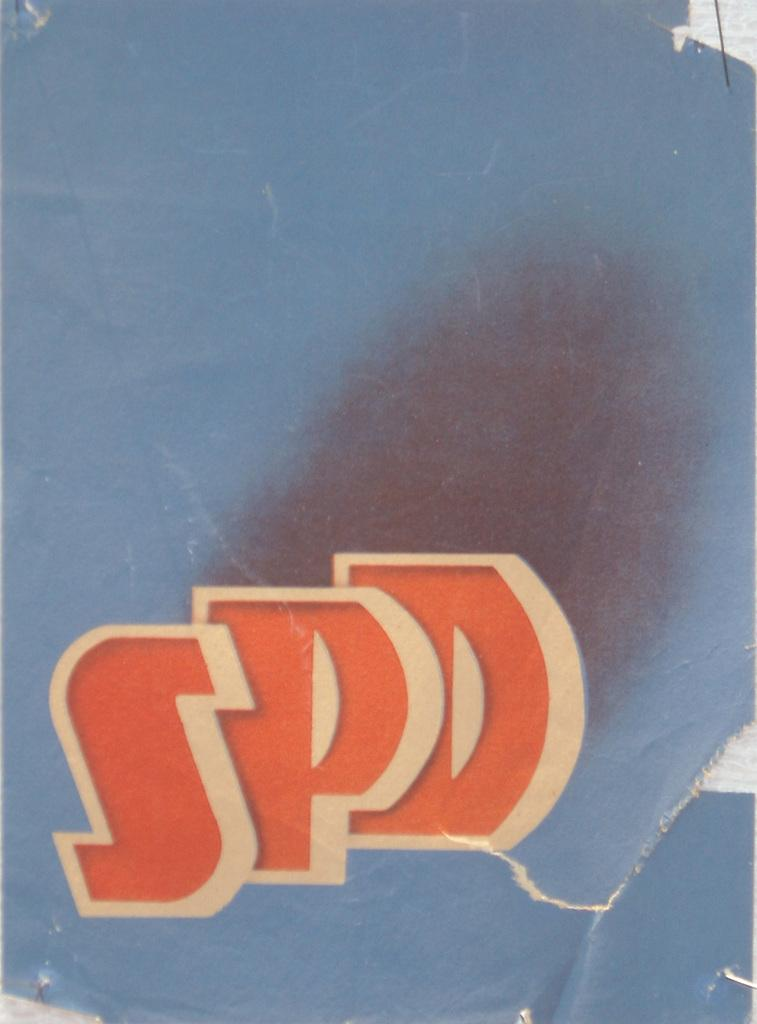<image>
Describe the image concisely. Three letters SPD are pictured on a blue back ground. 